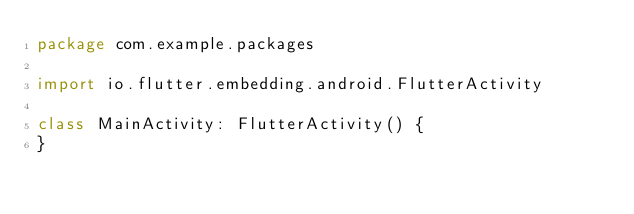<code> <loc_0><loc_0><loc_500><loc_500><_Kotlin_>package com.example.packages

import io.flutter.embedding.android.FlutterActivity

class MainActivity: FlutterActivity() {
}
</code> 